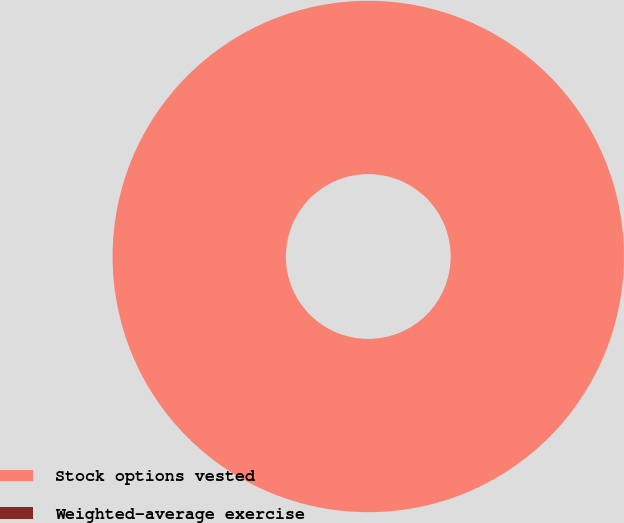Convert chart. <chart><loc_0><loc_0><loc_500><loc_500><pie_chart><fcel>Stock options vested<fcel>Weighted-average exercise<nl><fcel>100.0%<fcel>0.0%<nl></chart> 